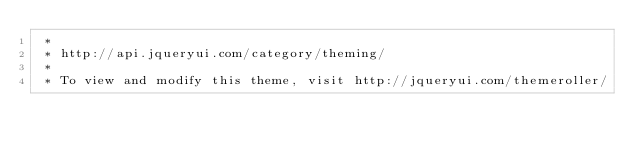<code> <loc_0><loc_0><loc_500><loc_500><_CSS_> *
 * http://api.jqueryui.com/category/theming/
 *
 * To view and modify this theme, visit http://jqueryui.com/themeroller/</code> 